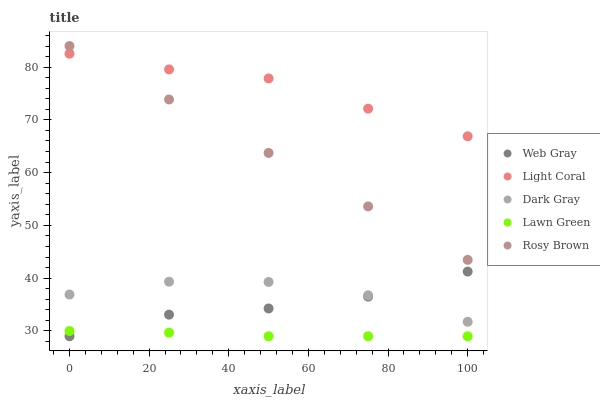Does Lawn Green have the minimum area under the curve?
Answer yes or no. Yes. Does Light Coral have the maximum area under the curve?
Answer yes or no. Yes. Does Dark Gray have the minimum area under the curve?
Answer yes or no. No. Does Dark Gray have the maximum area under the curve?
Answer yes or no. No. Is Rosy Brown the smoothest?
Answer yes or no. Yes. Is Dark Gray the roughest?
Answer yes or no. Yes. Is Dark Gray the smoothest?
Answer yes or no. No. Is Rosy Brown the roughest?
Answer yes or no. No. Does Web Gray have the lowest value?
Answer yes or no. Yes. Does Dark Gray have the lowest value?
Answer yes or no. No. Does Rosy Brown have the highest value?
Answer yes or no. Yes. Does Dark Gray have the highest value?
Answer yes or no. No. Is Lawn Green less than Dark Gray?
Answer yes or no. Yes. Is Rosy Brown greater than Lawn Green?
Answer yes or no. Yes. Does Web Gray intersect Lawn Green?
Answer yes or no. Yes. Is Web Gray less than Lawn Green?
Answer yes or no. No. Is Web Gray greater than Lawn Green?
Answer yes or no. No. Does Lawn Green intersect Dark Gray?
Answer yes or no. No. 